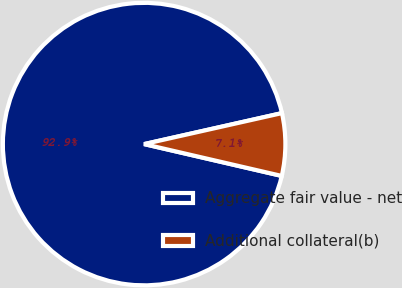<chart> <loc_0><loc_0><loc_500><loc_500><pie_chart><fcel>Aggregate fair value - net<fcel>Additional collateral(b)<nl><fcel>92.86%<fcel>7.14%<nl></chart> 